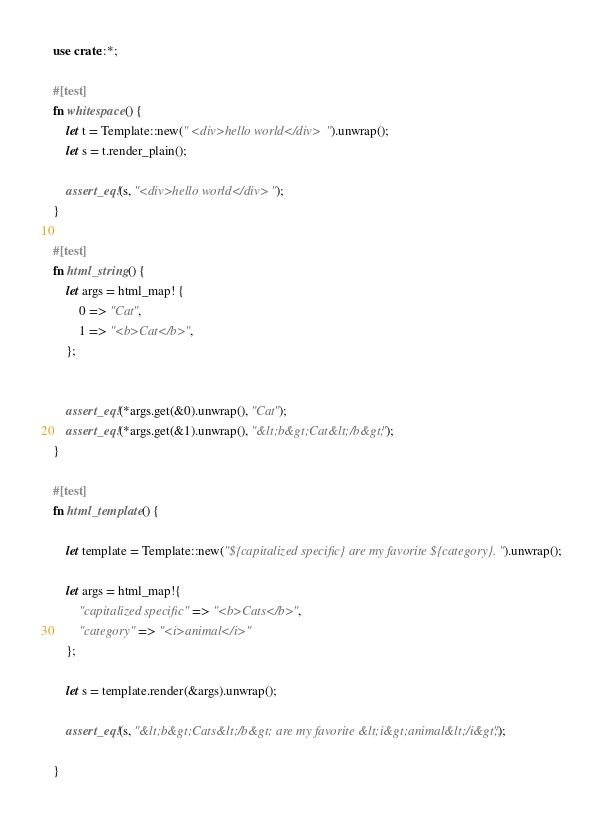Convert code to text. <code><loc_0><loc_0><loc_500><loc_500><_Rust_>use crate::*;

#[test]
fn whitespace() {
    let t = Template::new(" <div>hello world</div> ").unwrap();
    let s = t.render_plain();

    assert_eq!(s, "<div>hello world</div>");
}

#[test]
fn html_string() {
    let args = html_map! {
        0 => "Cat",
        1 => "<b>Cat</b>",
    };

    
    assert_eq!(*args.get(&0).unwrap(), "Cat");
    assert_eq!(*args.get(&1).unwrap(), "&lt;b&gt;Cat&lt;/b&gt;");
}

#[test]
fn html_template() {

    let template = Template::new("${capitalized specific} are my favorite ${category}.").unwrap();

    let args = html_map!{
        "capitalized specific" => "<b>Cats</b>",
        "category" => "<i>animal</i>"
    };

    let s = template.render(&args).unwrap();

    assert_eq!(s, "&lt;b&gt;Cats&lt;/b&gt; are my favorite &lt;i&gt;animal&lt;/i&gt;.");

}
</code> 